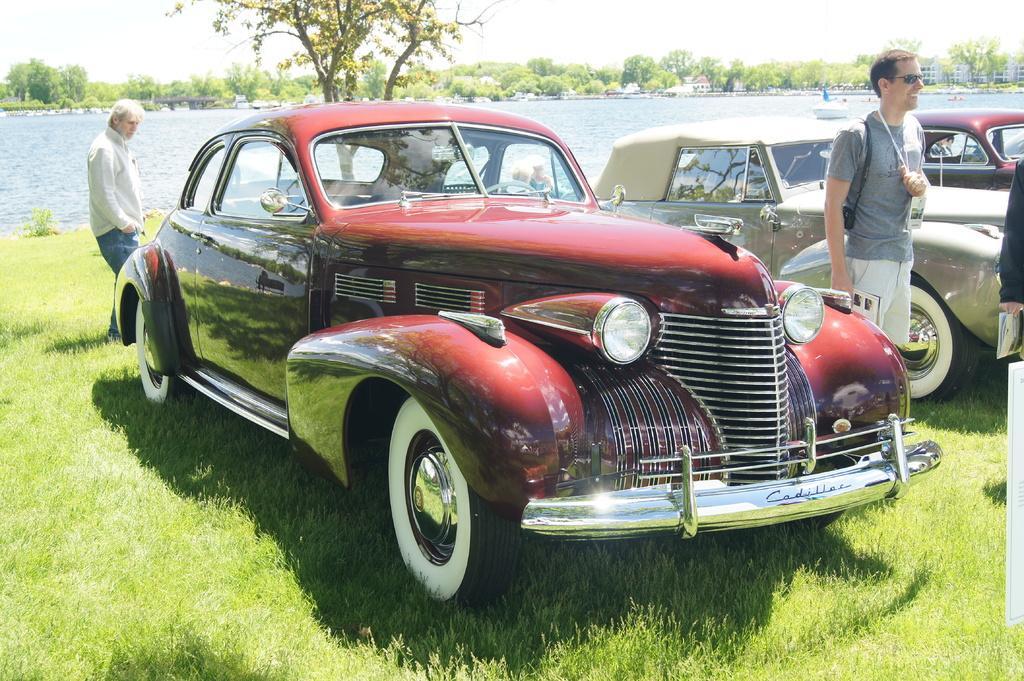Describe this image in one or two sentences. In this image we can see a few people and there are vehicles present. We can see a boat on the water and there are some trees and building in the background. 